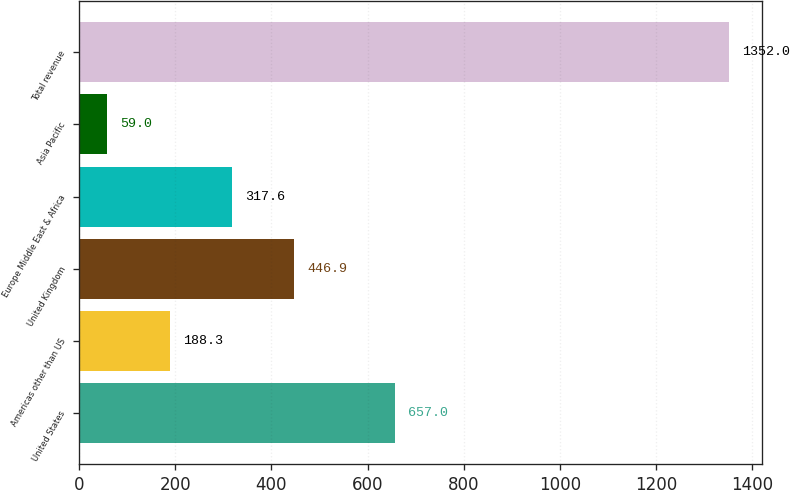Convert chart. <chart><loc_0><loc_0><loc_500><loc_500><bar_chart><fcel>United States<fcel>Americas other than US<fcel>United Kingdom<fcel>Europe Middle East & Africa<fcel>Asia Pacific<fcel>Total revenue<nl><fcel>657<fcel>188.3<fcel>446.9<fcel>317.6<fcel>59<fcel>1352<nl></chart> 